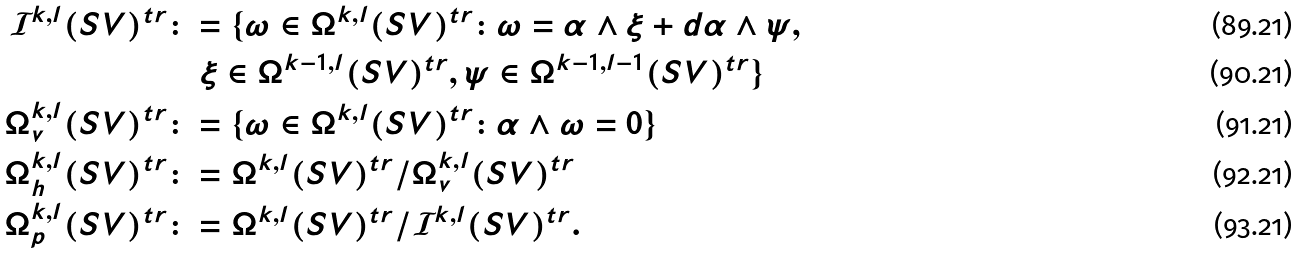<formula> <loc_0><loc_0><loc_500><loc_500>\mathcal { I } ^ { k , l } ( S V ) ^ { t r } & \colon = \{ \omega \in \Omega ^ { k , l } ( S V ) ^ { t r } \colon \omega = \alpha \wedge \xi + d \alpha \wedge \psi , \\ & \quad \xi \in \Omega ^ { k - 1 , l } ( S V ) ^ { t r } , \psi \in \Omega ^ { k - 1 , l - 1 } ( S V ) ^ { t r } \} \\ \Omega _ { v } ^ { k , l } ( S V ) ^ { t r } & \colon = \{ \omega \in \Omega ^ { k , l } ( S V ) ^ { t r } \colon \alpha \wedge \omega = 0 \} \\ \Omega _ { h } ^ { k , l } ( S V ) ^ { t r } & \colon = \Omega ^ { k , l } ( S V ) ^ { t r } / \Omega _ { v } ^ { k , l } ( S V ) ^ { t r } \\ \Omega _ { p } ^ { k , l } ( S V ) ^ { t r } & \colon = \Omega ^ { k , l } ( S V ) ^ { t r } / \mathcal { I } ^ { k , l } ( S V ) ^ { t r } .</formula> 